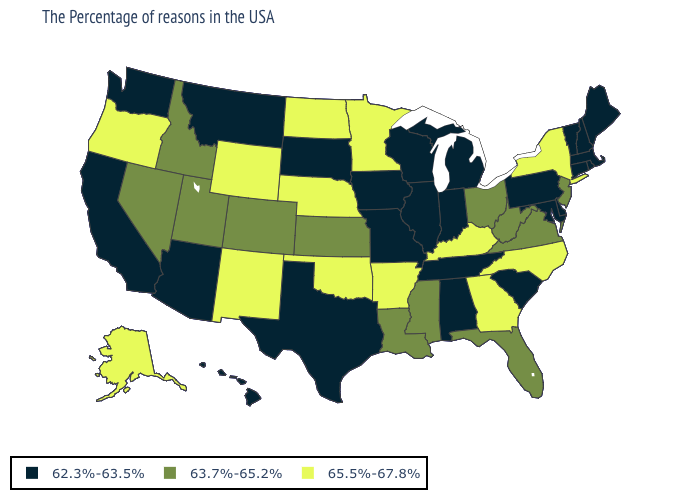What is the value of Oklahoma?
Short answer required. 65.5%-67.8%. Among the states that border Mississippi , does Alabama have the highest value?
Quick response, please. No. What is the lowest value in the USA?
Quick response, please. 62.3%-63.5%. What is the value of New York?
Give a very brief answer. 65.5%-67.8%. Name the states that have a value in the range 65.5%-67.8%?
Quick response, please. New York, North Carolina, Georgia, Kentucky, Arkansas, Minnesota, Nebraska, Oklahoma, North Dakota, Wyoming, New Mexico, Oregon, Alaska. Does the map have missing data?
Keep it brief. No. What is the value of New Hampshire?
Short answer required. 62.3%-63.5%. Which states have the lowest value in the West?
Write a very short answer. Montana, Arizona, California, Washington, Hawaii. Does Idaho have the lowest value in the USA?
Keep it brief. No. Name the states that have a value in the range 63.7%-65.2%?
Give a very brief answer. New Jersey, Virginia, West Virginia, Ohio, Florida, Mississippi, Louisiana, Kansas, Colorado, Utah, Idaho, Nevada. Does Washington have the highest value in the USA?
Short answer required. No. Which states have the lowest value in the West?
Answer briefly. Montana, Arizona, California, Washington, Hawaii. Does Missouri have the lowest value in the MidWest?
Concise answer only. Yes. Does Arizona have the highest value in the USA?
Short answer required. No. What is the value of Vermont?
Give a very brief answer. 62.3%-63.5%. 